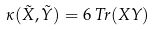Convert formula to latex. <formula><loc_0><loc_0><loc_500><loc_500>\kappa ( \tilde { X } , \tilde { Y } ) = 6 \, T r ( X Y )</formula> 